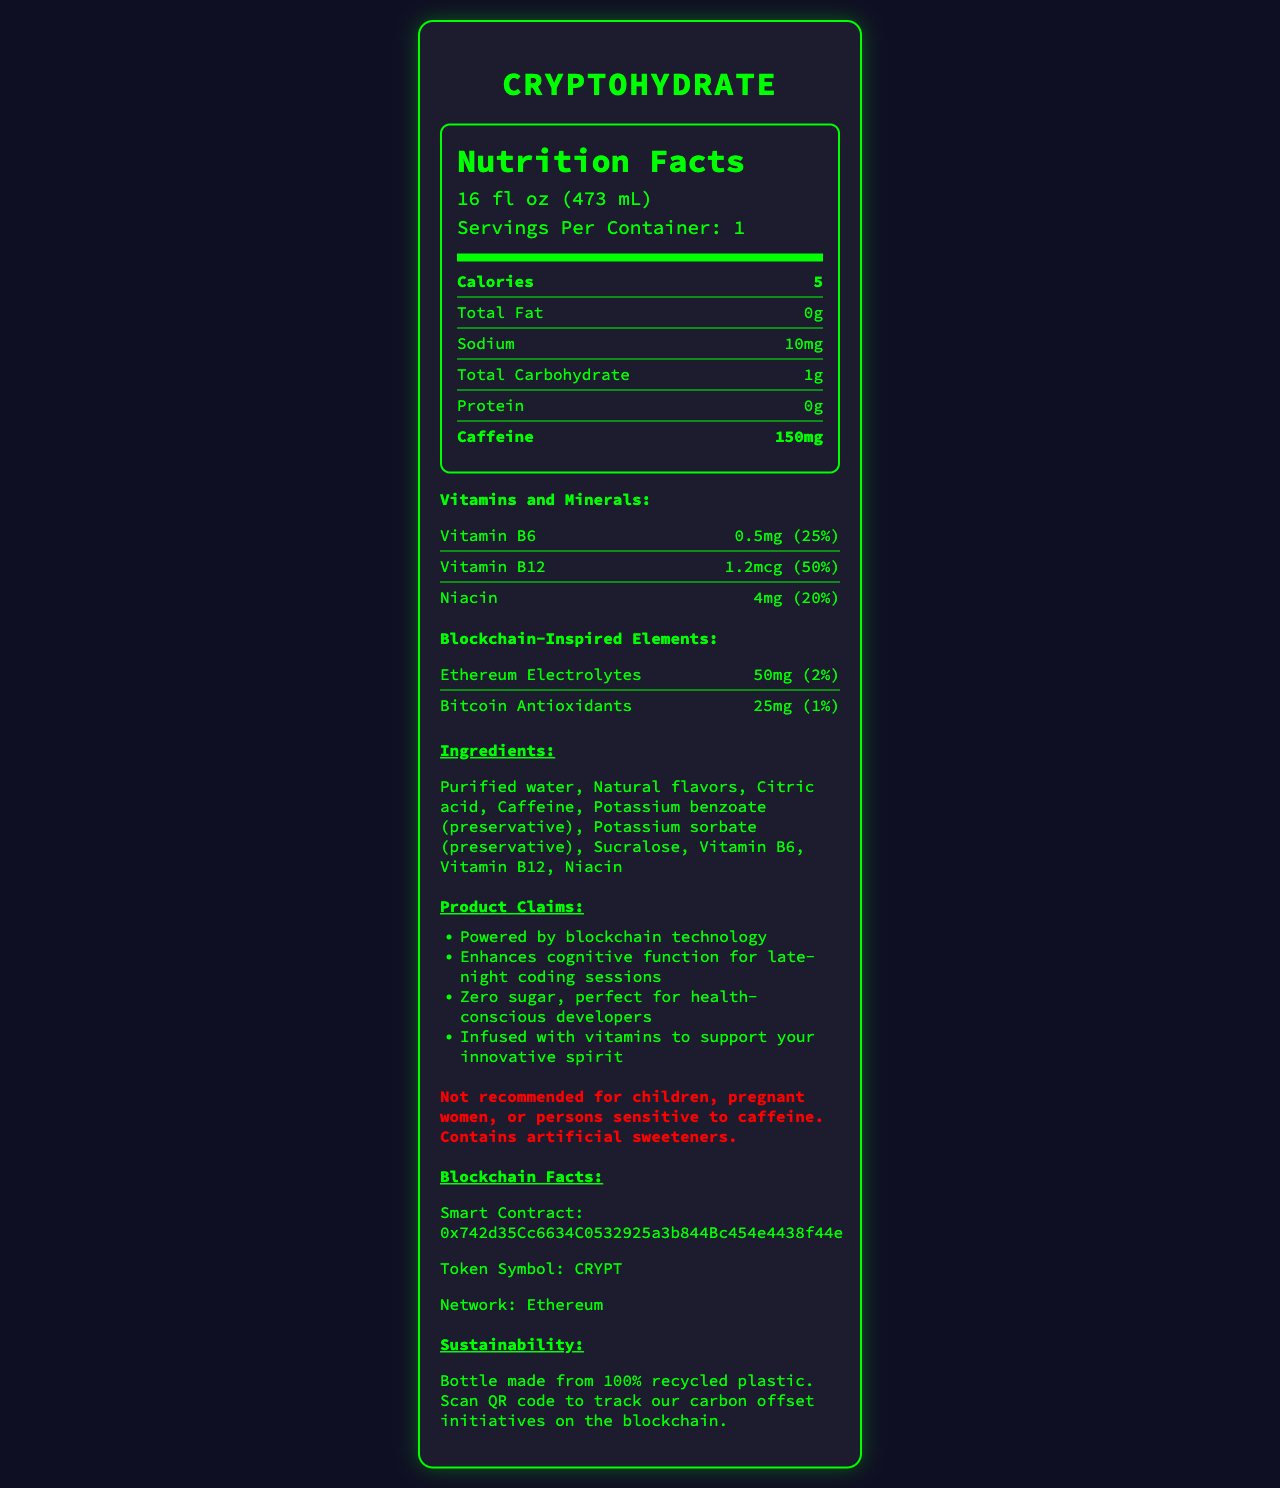what is the serving size of CryptoHydrate? The serving size is listed at the top of the nutrition label.
Answer: 16 fl oz (473 mL) how many calories are in a serving of CryptoHydrate? The nutrition label shows 5 calories under the Calories section.
Answer: 5 what is the amount of caffeine in a serving of CryptoHydrate? The nutrition label lists 150mg of caffeine as a bold item.
Answer: 150mg what vitamins are included in CryptoHydrate and in what amounts? The vitamins and their amounts are listed under the Vitamins and Minerals section.
Answer: Vitamin B6: 0.5mg, Vitamin B12: 1.2mcg, Niacin: 4mg what are the blockchain-inspired elements in CryptoHydrate? These elements are listed under the Blockchain-Inspired Elements section.
Answer: Ethereum Electrolytes: 50mg (2%), Bitcoin Antioxidants: 25mg (1%) which preservatives are used in CryptoHydrate? These ingredients are listed in the Ingredients section.
Answer: Potassium benzoate and Potassium sorbate what health-related marketing claims does CryptoHydrate make? These claims are listed under the Product Claims section.
Answer: Enhances cognitive function for late-night coding sessions; Zero sugar, perfect for health-conscious developers; Infused with vitamins to support your innovative spirit what warning comes with consuming CryptoHydrate? The warning is listed prominently in red text near the bottom.
Answer: Not recommended for children, pregnant women, or persons sensitive to caffeine. Contains artificial sweeteners. what is the product's smart contract address on the blockchain? The smart contract address is listed under the Blockchain Facts section.
Answer: 0x742d35Cc6634C0532925a3b844Bc454e4438f44e how much sodium does each serving contain? A. 5mg B. 10mg C. 15mg D. 20mg The nutrition label shows that CryptoHydrate has 10mg of sodium per serving.
Answer: B. 10mg what network is the product's blockchain on? A. Bitcoin B. Ethereum C. Litecoin D. Ripple The information provided under the Blockchain Facts section states that the blockchain network is Ethereum.
Answer: B. Ethereum is CryptoHydrate recommended for children? The warning section clearly states that it is not recommended for children.
Answer: No summarize the main features of CryptoHydrate. The document provides various details about the product, such as its nutritional content, ingredients, marketing claims, blockchain elements, warning, and sustainability info.
Answer: CryptoHydrate is a blockchain-branded, caffeine-infused bottled water with added vitamins and blockchain-inspired elements. It is designed to enhance cognitive function, is zero sugar, and comes with a number of health-related marketing claims. It also follows a sustainability initiative through its 100% recycled plastic bottle. Usage warnings and blockchain contract information are included. how exactly does CryptoHydrate enhance cognitive function? The document makes a marketing claim about enhancing cognitive function but does not provide specific details on how this is achieved.
Answer: Not enough information 